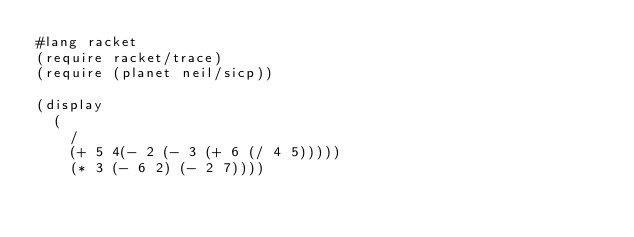Convert code to text. <code><loc_0><loc_0><loc_500><loc_500><_Scheme_>#lang racket
(require racket/trace)
(require (planet neil/sicp))

(display
  (
    /
    (+ 5 4(- 2 (- 3 (+ 6 (/ 4 5)))))
    (* 3 (- 6 2) (- 2 7))))
</code> 